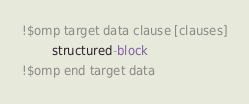Convert code to text. <code><loc_0><loc_0><loc_500><loc_500><_FORTRAN_>!$omp target data clause [clauses]
        structured-block
!$omp end target data
</code> 